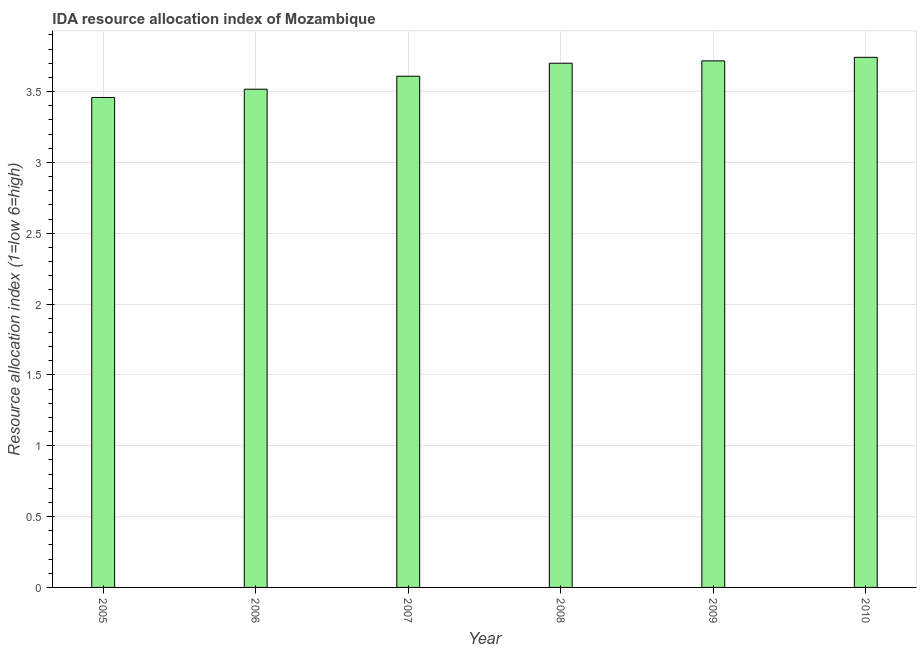Does the graph contain any zero values?
Your response must be concise. No. Does the graph contain grids?
Your response must be concise. Yes. What is the title of the graph?
Your response must be concise. IDA resource allocation index of Mozambique. What is the label or title of the Y-axis?
Provide a short and direct response. Resource allocation index (1=low 6=high). What is the ida resource allocation index in 2005?
Give a very brief answer. 3.46. Across all years, what is the maximum ida resource allocation index?
Provide a succinct answer. 3.74. Across all years, what is the minimum ida resource allocation index?
Offer a terse response. 3.46. In which year was the ida resource allocation index minimum?
Offer a terse response. 2005. What is the sum of the ida resource allocation index?
Provide a short and direct response. 21.74. What is the difference between the ida resource allocation index in 2007 and 2009?
Offer a terse response. -0.11. What is the average ida resource allocation index per year?
Make the answer very short. 3.62. What is the median ida resource allocation index?
Keep it short and to the point. 3.65. What is the ratio of the ida resource allocation index in 2008 to that in 2009?
Offer a terse response. 1. What is the difference between the highest and the second highest ida resource allocation index?
Make the answer very short. 0.03. What is the difference between the highest and the lowest ida resource allocation index?
Offer a terse response. 0.28. How many bars are there?
Provide a short and direct response. 6. How many years are there in the graph?
Ensure brevity in your answer.  6. Are the values on the major ticks of Y-axis written in scientific E-notation?
Provide a short and direct response. No. What is the Resource allocation index (1=low 6=high) of 2005?
Provide a succinct answer. 3.46. What is the Resource allocation index (1=low 6=high) in 2006?
Give a very brief answer. 3.52. What is the Resource allocation index (1=low 6=high) of 2007?
Provide a short and direct response. 3.61. What is the Resource allocation index (1=low 6=high) in 2008?
Provide a short and direct response. 3.7. What is the Resource allocation index (1=low 6=high) in 2009?
Your answer should be very brief. 3.72. What is the Resource allocation index (1=low 6=high) in 2010?
Offer a terse response. 3.74. What is the difference between the Resource allocation index (1=low 6=high) in 2005 and 2006?
Your response must be concise. -0.06. What is the difference between the Resource allocation index (1=low 6=high) in 2005 and 2008?
Provide a succinct answer. -0.24. What is the difference between the Resource allocation index (1=low 6=high) in 2005 and 2009?
Offer a very short reply. -0.26. What is the difference between the Resource allocation index (1=low 6=high) in 2005 and 2010?
Your answer should be compact. -0.28. What is the difference between the Resource allocation index (1=low 6=high) in 2006 and 2007?
Your answer should be compact. -0.09. What is the difference between the Resource allocation index (1=low 6=high) in 2006 and 2008?
Make the answer very short. -0.18. What is the difference between the Resource allocation index (1=low 6=high) in 2006 and 2010?
Offer a very short reply. -0.23. What is the difference between the Resource allocation index (1=low 6=high) in 2007 and 2008?
Your answer should be very brief. -0.09. What is the difference between the Resource allocation index (1=low 6=high) in 2007 and 2009?
Provide a short and direct response. -0.11. What is the difference between the Resource allocation index (1=low 6=high) in 2007 and 2010?
Your answer should be very brief. -0.13. What is the difference between the Resource allocation index (1=low 6=high) in 2008 and 2009?
Your response must be concise. -0.02. What is the difference between the Resource allocation index (1=low 6=high) in 2008 and 2010?
Offer a terse response. -0.04. What is the difference between the Resource allocation index (1=low 6=high) in 2009 and 2010?
Keep it short and to the point. -0.03. What is the ratio of the Resource allocation index (1=low 6=high) in 2005 to that in 2007?
Provide a short and direct response. 0.96. What is the ratio of the Resource allocation index (1=low 6=high) in 2005 to that in 2008?
Your response must be concise. 0.94. What is the ratio of the Resource allocation index (1=low 6=high) in 2005 to that in 2010?
Make the answer very short. 0.92. What is the ratio of the Resource allocation index (1=low 6=high) in 2006 to that in 2007?
Ensure brevity in your answer.  0.97. What is the ratio of the Resource allocation index (1=low 6=high) in 2006 to that in 2009?
Your answer should be compact. 0.95. What is the ratio of the Resource allocation index (1=low 6=high) in 2006 to that in 2010?
Offer a terse response. 0.94. What is the ratio of the Resource allocation index (1=low 6=high) in 2007 to that in 2009?
Offer a terse response. 0.97. What is the ratio of the Resource allocation index (1=low 6=high) in 2007 to that in 2010?
Offer a very short reply. 0.96. What is the ratio of the Resource allocation index (1=low 6=high) in 2008 to that in 2009?
Your answer should be very brief. 1. What is the ratio of the Resource allocation index (1=low 6=high) in 2009 to that in 2010?
Offer a very short reply. 0.99. 